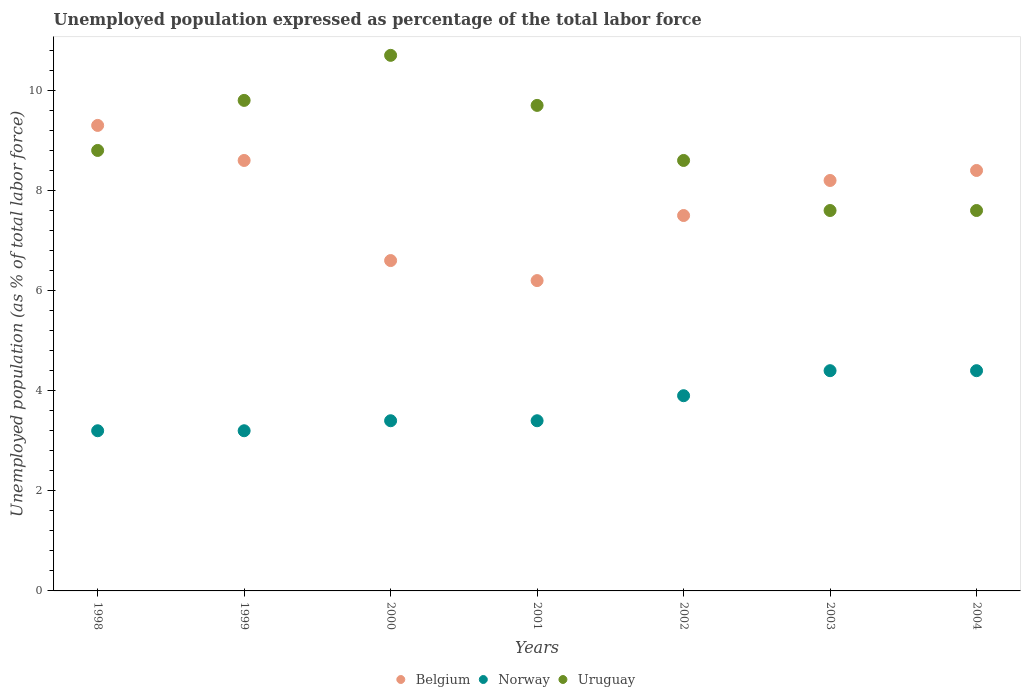Is the number of dotlines equal to the number of legend labels?
Make the answer very short. Yes. What is the unemployment in in Norway in 2003?
Your answer should be very brief. 4.4. Across all years, what is the maximum unemployment in in Uruguay?
Give a very brief answer. 10.7. Across all years, what is the minimum unemployment in in Belgium?
Your response must be concise. 6.2. In which year was the unemployment in in Norway maximum?
Your answer should be very brief. 2003. In which year was the unemployment in in Uruguay minimum?
Your answer should be very brief. 2003. What is the total unemployment in in Belgium in the graph?
Your answer should be very brief. 54.8. What is the difference between the unemployment in in Uruguay in 2000 and that in 2003?
Ensure brevity in your answer.  3.1. What is the difference between the unemployment in in Norway in 2003 and the unemployment in in Uruguay in 1999?
Provide a succinct answer. -5.4. What is the average unemployment in in Uruguay per year?
Provide a succinct answer. 8.97. In the year 2004, what is the difference between the unemployment in in Belgium and unemployment in in Uruguay?
Your answer should be compact. 0.8. What is the ratio of the unemployment in in Belgium in 2003 to that in 2004?
Offer a very short reply. 0.98. Is the difference between the unemployment in in Belgium in 2000 and 2002 greater than the difference between the unemployment in in Uruguay in 2000 and 2002?
Offer a terse response. No. What is the difference between the highest and the second highest unemployment in in Uruguay?
Ensure brevity in your answer.  0.9. What is the difference between the highest and the lowest unemployment in in Belgium?
Provide a succinct answer. 3.1. Is the sum of the unemployment in in Belgium in 2001 and 2002 greater than the maximum unemployment in in Uruguay across all years?
Ensure brevity in your answer.  Yes. Does the unemployment in in Uruguay monotonically increase over the years?
Offer a very short reply. No. Is the unemployment in in Belgium strictly greater than the unemployment in in Uruguay over the years?
Offer a very short reply. No. Is the unemployment in in Norway strictly less than the unemployment in in Belgium over the years?
Ensure brevity in your answer.  Yes. What is the difference between two consecutive major ticks on the Y-axis?
Give a very brief answer. 2. Are the values on the major ticks of Y-axis written in scientific E-notation?
Provide a succinct answer. No. Does the graph contain grids?
Make the answer very short. No. Where does the legend appear in the graph?
Offer a very short reply. Bottom center. How many legend labels are there?
Your answer should be compact. 3. What is the title of the graph?
Give a very brief answer. Unemployed population expressed as percentage of the total labor force. What is the label or title of the Y-axis?
Provide a succinct answer. Unemployed population (as % of total labor force). What is the Unemployed population (as % of total labor force) in Belgium in 1998?
Give a very brief answer. 9.3. What is the Unemployed population (as % of total labor force) of Norway in 1998?
Provide a short and direct response. 3.2. What is the Unemployed population (as % of total labor force) of Uruguay in 1998?
Your answer should be compact. 8.8. What is the Unemployed population (as % of total labor force) in Belgium in 1999?
Your answer should be very brief. 8.6. What is the Unemployed population (as % of total labor force) in Norway in 1999?
Your answer should be compact. 3.2. What is the Unemployed population (as % of total labor force) of Uruguay in 1999?
Your answer should be compact. 9.8. What is the Unemployed population (as % of total labor force) of Belgium in 2000?
Offer a very short reply. 6.6. What is the Unemployed population (as % of total labor force) of Norway in 2000?
Offer a very short reply. 3.4. What is the Unemployed population (as % of total labor force) in Uruguay in 2000?
Keep it short and to the point. 10.7. What is the Unemployed population (as % of total labor force) of Belgium in 2001?
Ensure brevity in your answer.  6.2. What is the Unemployed population (as % of total labor force) of Norway in 2001?
Your answer should be compact. 3.4. What is the Unemployed population (as % of total labor force) in Uruguay in 2001?
Provide a succinct answer. 9.7. What is the Unemployed population (as % of total labor force) in Norway in 2002?
Ensure brevity in your answer.  3.9. What is the Unemployed population (as % of total labor force) of Uruguay in 2002?
Your answer should be compact. 8.6. What is the Unemployed population (as % of total labor force) of Belgium in 2003?
Offer a very short reply. 8.2. What is the Unemployed population (as % of total labor force) in Norway in 2003?
Provide a succinct answer. 4.4. What is the Unemployed population (as % of total labor force) in Uruguay in 2003?
Provide a short and direct response. 7.6. What is the Unemployed population (as % of total labor force) in Belgium in 2004?
Provide a succinct answer. 8.4. What is the Unemployed population (as % of total labor force) in Norway in 2004?
Your answer should be very brief. 4.4. What is the Unemployed population (as % of total labor force) in Uruguay in 2004?
Your answer should be very brief. 7.6. Across all years, what is the maximum Unemployed population (as % of total labor force) of Belgium?
Make the answer very short. 9.3. Across all years, what is the maximum Unemployed population (as % of total labor force) of Norway?
Make the answer very short. 4.4. Across all years, what is the maximum Unemployed population (as % of total labor force) of Uruguay?
Your response must be concise. 10.7. Across all years, what is the minimum Unemployed population (as % of total labor force) in Belgium?
Provide a succinct answer. 6.2. Across all years, what is the minimum Unemployed population (as % of total labor force) of Norway?
Provide a short and direct response. 3.2. Across all years, what is the minimum Unemployed population (as % of total labor force) of Uruguay?
Keep it short and to the point. 7.6. What is the total Unemployed population (as % of total labor force) in Belgium in the graph?
Offer a very short reply. 54.8. What is the total Unemployed population (as % of total labor force) in Norway in the graph?
Your answer should be compact. 25.9. What is the total Unemployed population (as % of total labor force) in Uruguay in the graph?
Keep it short and to the point. 62.8. What is the difference between the Unemployed population (as % of total labor force) of Belgium in 1998 and that in 1999?
Give a very brief answer. 0.7. What is the difference between the Unemployed population (as % of total labor force) of Norway in 1998 and that in 2000?
Offer a terse response. -0.2. What is the difference between the Unemployed population (as % of total labor force) of Belgium in 1998 and that in 2001?
Keep it short and to the point. 3.1. What is the difference between the Unemployed population (as % of total labor force) in Uruguay in 1998 and that in 2001?
Ensure brevity in your answer.  -0.9. What is the difference between the Unemployed population (as % of total labor force) of Belgium in 1998 and that in 2002?
Offer a very short reply. 1.8. What is the difference between the Unemployed population (as % of total labor force) in Norway in 1998 and that in 2002?
Your answer should be compact. -0.7. What is the difference between the Unemployed population (as % of total labor force) of Belgium in 1998 and that in 2003?
Your answer should be compact. 1.1. What is the difference between the Unemployed population (as % of total labor force) of Uruguay in 1998 and that in 2004?
Provide a succinct answer. 1.2. What is the difference between the Unemployed population (as % of total labor force) in Belgium in 1999 and that in 2001?
Provide a succinct answer. 2.4. What is the difference between the Unemployed population (as % of total labor force) in Norway in 1999 and that in 2002?
Provide a succinct answer. -0.7. What is the difference between the Unemployed population (as % of total labor force) of Uruguay in 1999 and that in 2002?
Your answer should be compact. 1.2. What is the difference between the Unemployed population (as % of total labor force) in Belgium in 1999 and that in 2003?
Offer a very short reply. 0.4. What is the difference between the Unemployed population (as % of total labor force) of Norway in 1999 and that in 2003?
Keep it short and to the point. -1.2. What is the difference between the Unemployed population (as % of total labor force) in Uruguay in 1999 and that in 2003?
Your answer should be very brief. 2.2. What is the difference between the Unemployed population (as % of total labor force) of Norway in 1999 and that in 2004?
Provide a short and direct response. -1.2. What is the difference between the Unemployed population (as % of total labor force) in Uruguay in 1999 and that in 2004?
Provide a short and direct response. 2.2. What is the difference between the Unemployed population (as % of total labor force) of Norway in 2000 and that in 2001?
Ensure brevity in your answer.  0. What is the difference between the Unemployed population (as % of total labor force) of Belgium in 2000 and that in 2002?
Your answer should be very brief. -0.9. What is the difference between the Unemployed population (as % of total labor force) of Norway in 2000 and that in 2002?
Ensure brevity in your answer.  -0.5. What is the difference between the Unemployed population (as % of total labor force) in Belgium in 2000 and that in 2004?
Your answer should be compact. -1.8. What is the difference between the Unemployed population (as % of total labor force) in Norway in 2000 and that in 2004?
Your answer should be very brief. -1. What is the difference between the Unemployed population (as % of total labor force) of Norway in 2001 and that in 2002?
Provide a succinct answer. -0.5. What is the difference between the Unemployed population (as % of total labor force) of Uruguay in 2001 and that in 2002?
Offer a terse response. 1.1. What is the difference between the Unemployed population (as % of total labor force) of Belgium in 2001 and that in 2004?
Your response must be concise. -2.2. What is the difference between the Unemployed population (as % of total labor force) in Uruguay in 2001 and that in 2004?
Offer a terse response. 2.1. What is the difference between the Unemployed population (as % of total labor force) in Belgium in 2002 and that in 2004?
Ensure brevity in your answer.  -0.9. What is the difference between the Unemployed population (as % of total labor force) in Norway in 2002 and that in 2004?
Provide a succinct answer. -0.5. What is the difference between the Unemployed population (as % of total labor force) in Uruguay in 2002 and that in 2004?
Your response must be concise. 1. What is the difference between the Unemployed population (as % of total labor force) in Norway in 1998 and the Unemployed population (as % of total labor force) in Uruguay in 1999?
Your answer should be compact. -6.6. What is the difference between the Unemployed population (as % of total labor force) of Norway in 1998 and the Unemployed population (as % of total labor force) of Uruguay in 2000?
Make the answer very short. -7.5. What is the difference between the Unemployed population (as % of total labor force) in Belgium in 1998 and the Unemployed population (as % of total labor force) in Uruguay in 2001?
Offer a very short reply. -0.4. What is the difference between the Unemployed population (as % of total labor force) in Belgium in 1998 and the Unemployed population (as % of total labor force) in Uruguay in 2002?
Give a very brief answer. 0.7. What is the difference between the Unemployed population (as % of total labor force) in Belgium in 1998 and the Unemployed population (as % of total labor force) in Norway in 2003?
Ensure brevity in your answer.  4.9. What is the difference between the Unemployed population (as % of total labor force) of Belgium in 1998 and the Unemployed population (as % of total labor force) of Uruguay in 2003?
Provide a short and direct response. 1.7. What is the difference between the Unemployed population (as % of total labor force) in Belgium in 1999 and the Unemployed population (as % of total labor force) in Norway in 2001?
Give a very brief answer. 5.2. What is the difference between the Unemployed population (as % of total labor force) in Belgium in 1999 and the Unemployed population (as % of total labor force) in Uruguay in 2001?
Offer a terse response. -1.1. What is the difference between the Unemployed population (as % of total labor force) in Norway in 1999 and the Unemployed population (as % of total labor force) in Uruguay in 2001?
Make the answer very short. -6.5. What is the difference between the Unemployed population (as % of total labor force) of Belgium in 1999 and the Unemployed population (as % of total labor force) of Norway in 2002?
Offer a terse response. 4.7. What is the difference between the Unemployed population (as % of total labor force) in Norway in 1999 and the Unemployed population (as % of total labor force) in Uruguay in 2004?
Your answer should be compact. -4.4. What is the difference between the Unemployed population (as % of total labor force) in Norway in 2000 and the Unemployed population (as % of total labor force) in Uruguay in 2001?
Provide a succinct answer. -6.3. What is the difference between the Unemployed population (as % of total labor force) in Norway in 2000 and the Unemployed population (as % of total labor force) in Uruguay in 2003?
Keep it short and to the point. -4.2. What is the difference between the Unemployed population (as % of total labor force) in Belgium in 2000 and the Unemployed population (as % of total labor force) in Uruguay in 2004?
Your response must be concise. -1. What is the difference between the Unemployed population (as % of total labor force) in Norway in 2000 and the Unemployed population (as % of total labor force) in Uruguay in 2004?
Provide a short and direct response. -4.2. What is the difference between the Unemployed population (as % of total labor force) of Belgium in 2001 and the Unemployed population (as % of total labor force) of Uruguay in 2002?
Give a very brief answer. -2.4. What is the difference between the Unemployed population (as % of total labor force) in Norway in 2001 and the Unemployed population (as % of total labor force) in Uruguay in 2002?
Provide a short and direct response. -5.2. What is the difference between the Unemployed population (as % of total labor force) in Belgium in 2001 and the Unemployed population (as % of total labor force) in Uruguay in 2003?
Give a very brief answer. -1.4. What is the difference between the Unemployed population (as % of total labor force) in Norway in 2001 and the Unemployed population (as % of total labor force) in Uruguay in 2003?
Your answer should be very brief. -4.2. What is the difference between the Unemployed population (as % of total labor force) in Belgium in 2001 and the Unemployed population (as % of total labor force) in Norway in 2004?
Your answer should be very brief. 1.8. What is the difference between the Unemployed population (as % of total labor force) in Belgium in 2001 and the Unemployed population (as % of total labor force) in Uruguay in 2004?
Offer a very short reply. -1.4. What is the difference between the Unemployed population (as % of total labor force) in Belgium in 2002 and the Unemployed population (as % of total labor force) in Norway in 2003?
Provide a succinct answer. 3.1. What is the difference between the Unemployed population (as % of total labor force) of Norway in 2002 and the Unemployed population (as % of total labor force) of Uruguay in 2003?
Make the answer very short. -3.7. What is the difference between the Unemployed population (as % of total labor force) in Belgium in 2002 and the Unemployed population (as % of total labor force) in Uruguay in 2004?
Provide a succinct answer. -0.1. What is the difference between the Unemployed population (as % of total labor force) in Belgium in 2003 and the Unemployed population (as % of total labor force) in Norway in 2004?
Give a very brief answer. 3.8. What is the average Unemployed population (as % of total labor force) of Belgium per year?
Give a very brief answer. 7.83. What is the average Unemployed population (as % of total labor force) of Norway per year?
Provide a succinct answer. 3.7. What is the average Unemployed population (as % of total labor force) of Uruguay per year?
Keep it short and to the point. 8.97. In the year 2000, what is the difference between the Unemployed population (as % of total labor force) in Belgium and Unemployed population (as % of total labor force) in Uruguay?
Make the answer very short. -4.1. In the year 2000, what is the difference between the Unemployed population (as % of total labor force) in Norway and Unemployed population (as % of total labor force) in Uruguay?
Make the answer very short. -7.3. In the year 2001, what is the difference between the Unemployed population (as % of total labor force) in Belgium and Unemployed population (as % of total labor force) in Norway?
Ensure brevity in your answer.  2.8. In the year 2002, what is the difference between the Unemployed population (as % of total labor force) of Belgium and Unemployed population (as % of total labor force) of Uruguay?
Your answer should be compact. -1.1. In the year 2003, what is the difference between the Unemployed population (as % of total labor force) in Belgium and Unemployed population (as % of total labor force) in Norway?
Your answer should be very brief. 3.8. In the year 2003, what is the difference between the Unemployed population (as % of total labor force) in Norway and Unemployed population (as % of total labor force) in Uruguay?
Offer a very short reply. -3.2. In the year 2004, what is the difference between the Unemployed population (as % of total labor force) of Belgium and Unemployed population (as % of total labor force) of Norway?
Provide a short and direct response. 4. In the year 2004, what is the difference between the Unemployed population (as % of total labor force) in Belgium and Unemployed population (as % of total labor force) in Uruguay?
Make the answer very short. 0.8. In the year 2004, what is the difference between the Unemployed population (as % of total labor force) in Norway and Unemployed population (as % of total labor force) in Uruguay?
Your response must be concise. -3.2. What is the ratio of the Unemployed population (as % of total labor force) in Belgium in 1998 to that in 1999?
Your response must be concise. 1.08. What is the ratio of the Unemployed population (as % of total labor force) in Norway in 1998 to that in 1999?
Offer a very short reply. 1. What is the ratio of the Unemployed population (as % of total labor force) of Uruguay in 1998 to that in 1999?
Make the answer very short. 0.9. What is the ratio of the Unemployed population (as % of total labor force) in Belgium in 1998 to that in 2000?
Provide a short and direct response. 1.41. What is the ratio of the Unemployed population (as % of total labor force) of Uruguay in 1998 to that in 2000?
Your answer should be compact. 0.82. What is the ratio of the Unemployed population (as % of total labor force) in Norway in 1998 to that in 2001?
Ensure brevity in your answer.  0.94. What is the ratio of the Unemployed population (as % of total labor force) in Uruguay in 1998 to that in 2001?
Make the answer very short. 0.91. What is the ratio of the Unemployed population (as % of total labor force) in Belgium in 1998 to that in 2002?
Offer a terse response. 1.24. What is the ratio of the Unemployed population (as % of total labor force) in Norway in 1998 to that in 2002?
Provide a short and direct response. 0.82. What is the ratio of the Unemployed population (as % of total labor force) of Uruguay in 1998 to that in 2002?
Your answer should be compact. 1.02. What is the ratio of the Unemployed population (as % of total labor force) of Belgium in 1998 to that in 2003?
Keep it short and to the point. 1.13. What is the ratio of the Unemployed population (as % of total labor force) in Norway in 1998 to that in 2003?
Ensure brevity in your answer.  0.73. What is the ratio of the Unemployed population (as % of total labor force) in Uruguay in 1998 to that in 2003?
Your response must be concise. 1.16. What is the ratio of the Unemployed population (as % of total labor force) in Belgium in 1998 to that in 2004?
Give a very brief answer. 1.11. What is the ratio of the Unemployed population (as % of total labor force) of Norway in 1998 to that in 2004?
Make the answer very short. 0.73. What is the ratio of the Unemployed population (as % of total labor force) in Uruguay in 1998 to that in 2004?
Give a very brief answer. 1.16. What is the ratio of the Unemployed population (as % of total labor force) of Belgium in 1999 to that in 2000?
Give a very brief answer. 1.3. What is the ratio of the Unemployed population (as % of total labor force) in Norway in 1999 to that in 2000?
Offer a terse response. 0.94. What is the ratio of the Unemployed population (as % of total labor force) in Uruguay in 1999 to that in 2000?
Provide a short and direct response. 0.92. What is the ratio of the Unemployed population (as % of total labor force) in Belgium in 1999 to that in 2001?
Your answer should be compact. 1.39. What is the ratio of the Unemployed population (as % of total labor force) in Norway in 1999 to that in 2001?
Offer a very short reply. 0.94. What is the ratio of the Unemployed population (as % of total labor force) in Uruguay in 1999 to that in 2001?
Provide a short and direct response. 1.01. What is the ratio of the Unemployed population (as % of total labor force) in Belgium in 1999 to that in 2002?
Your answer should be very brief. 1.15. What is the ratio of the Unemployed population (as % of total labor force) in Norway in 1999 to that in 2002?
Make the answer very short. 0.82. What is the ratio of the Unemployed population (as % of total labor force) of Uruguay in 1999 to that in 2002?
Provide a short and direct response. 1.14. What is the ratio of the Unemployed population (as % of total labor force) in Belgium in 1999 to that in 2003?
Provide a short and direct response. 1.05. What is the ratio of the Unemployed population (as % of total labor force) of Norway in 1999 to that in 2003?
Provide a succinct answer. 0.73. What is the ratio of the Unemployed population (as % of total labor force) of Uruguay in 1999 to that in 2003?
Keep it short and to the point. 1.29. What is the ratio of the Unemployed population (as % of total labor force) in Belgium in 1999 to that in 2004?
Give a very brief answer. 1.02. What is the ratio of the Unemployed population (as % of total labor force) in Norway in 1999 to that in 2004?
Your response must be concise. 0.73. What is the ratio of the Unemployed population (as % of total labor force) in Uruguay in 1999 to that in 2004?
Provide a succinct answer. 1.29. What is the ratio of the Unemployed population (as % of total labor force) in Belgium in 2000 to that in 2001?
Give a very brief answer. 1.06. What is the ratio of the Unemployed population (as % of total labor force) in Uruguay in 2000 to that in 2001?
Your answer should be compact. 1.1. What is the ratio of the Unemployed population (as % of total labor force) of Norway in 2000 to that in 2002?
Your answer should be compact. 0.87. What is the ratio of the Unemployed population (as % of total labor force) of Uruguay in 2000 to that in 2002?
Your answer should be compact. 1.24. What is the ratio of the Unemployed population (as % of total labor force) of Belgium in 2000 to that in 2003?
Your answer should be very brief. 0.8. What is the ratio of the Unemployed population (as % of total labor force) of Norway in 2000 to that in 2003?
Ensure brevity in your answer.  0.77. What is the ratio of the Unemployed population (as % of total labor force) of Uruguay in 2000 to that in 2003?
Give a very brief answer. 1.41. What is the ratio of the Unemployed population (as % of total labor force) of Belgium in 2000 to that in 2004?
Offer a terse response. 0.79. What is the ratio of the Unemployed population (as % of total labor force) of Norway in 2000 to that in 2004?
Provide a succinct answer. 0.77. What is the ratio of the Unemployed population (as % of total labor force) in Uruguay in 2000 to that in 2004?
Your answer should be compact. 1.41. What is the ratio of the Unemployed population (as % of total labor force) of Belgium in 2001 to that in 2002?
Give a very brief answer. 0.83. What is the ratio of the Unemployed population (as % of total labor force) in Norway in 2001 to that in 2002?
Your answer should be compact. 0.87. What is the ratio of the Unemployed population (as % of total labor force) of Uruguay in 2001 to that in 2002?
Offer a terse response. 1.13. What is the ratio of the Unemployed population (as % of total labor force) of Belgium in 2001 to that in 2003?
Make the answer very short. 0.76. What is the ratio of the Unemployed population (as % of total labor force) of Norway in 2001 to that in 2003?
Offer a very short reply. 0.77. What is the ratio of the Unemployed population (as % of total labor force) of Uruguay in 2001 to that in 2003?
Keep it short and to the point. 1.28. What is the ratio of the Unemployed population (as % of total labor force) in Belgium in 2001 to that in 2004?
Offer a terse response. 0.74. What is the ratio of the Unemployed population (as % of total labor force) of Norway in 2001 to that in 2004?
Your response must be concise. 0.77. What is the ratio of the Unemployed population (as % of total labor force) of Uruguay in 2001 to that in 2004?
Offer a terse response. 1.28. What is the ratio of the Unemployed population (as % of total labor force) in Belgium in 2002 to that in 2003?
Your answer should be very brief. 0.91. What is the ratio of the Unemployed population (as % of total labor force) in Norway in 2002 to that in 2003?
Your answer should be compact. 0.89. What is the ratio of the Unemployed population (as % of total labor force) of Uruguay in 2002 to that in 2003?
Offer a terse response. 1.13. What is the ratio of the Unemployed population (as % of total labor force) in Belgium in 2002 to that in 2004?
Keep it short and to the point. 0.89. What is the ratio of the Unemployed population (as % of total labor force) in Norway in 2002 to that in 2004?
Your response must be concise. 0.89. What is the ratio of the Unemployed population (as % of total labor force) of Uruguay in 2002 to that in 2004?
Offer a terse response. 1.13. What is the ratio of the Unemployed population (as % of total labor force) of Belgium in 2003 to that in 2004?
Your response must be concise. 0.98. What is the ratio of the Unemployed population (as % of total labor force) in Norway in 2003 to that in 2004?
Provide a succinct answer. 1. What is the ratio of the Unemployed population (as % of total labor force) in Uruguay in 2003 to that in 2004?
Make the answer very short. 1. What is the difference between the highest and the second highest Unemployed population (as % of total labor force) in Norway?
Give a very brief answer. 0. What is the difference between the highest and the second highest Unemployed population (as % of total labor force) of Uruguay?
Your answer should be very brief. 0.9. What is the difference between the highest and the lowest Unemployed population (as % of total labor force) in Belgium?
Give a very brief answer. 3.1. What is the difference between the highest and the lowest Unemployed population (as % of total labor force) of Uruguay?
Ensure brevity in your answer.  3.1. 